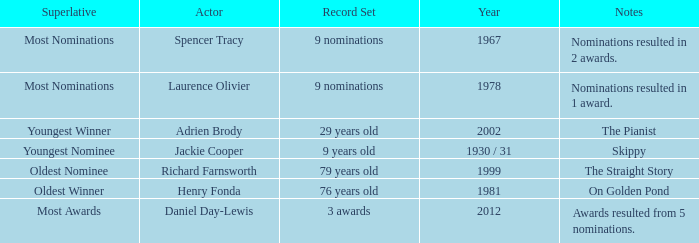What year was the the youngest nominee a winner? 1930 / 31. 